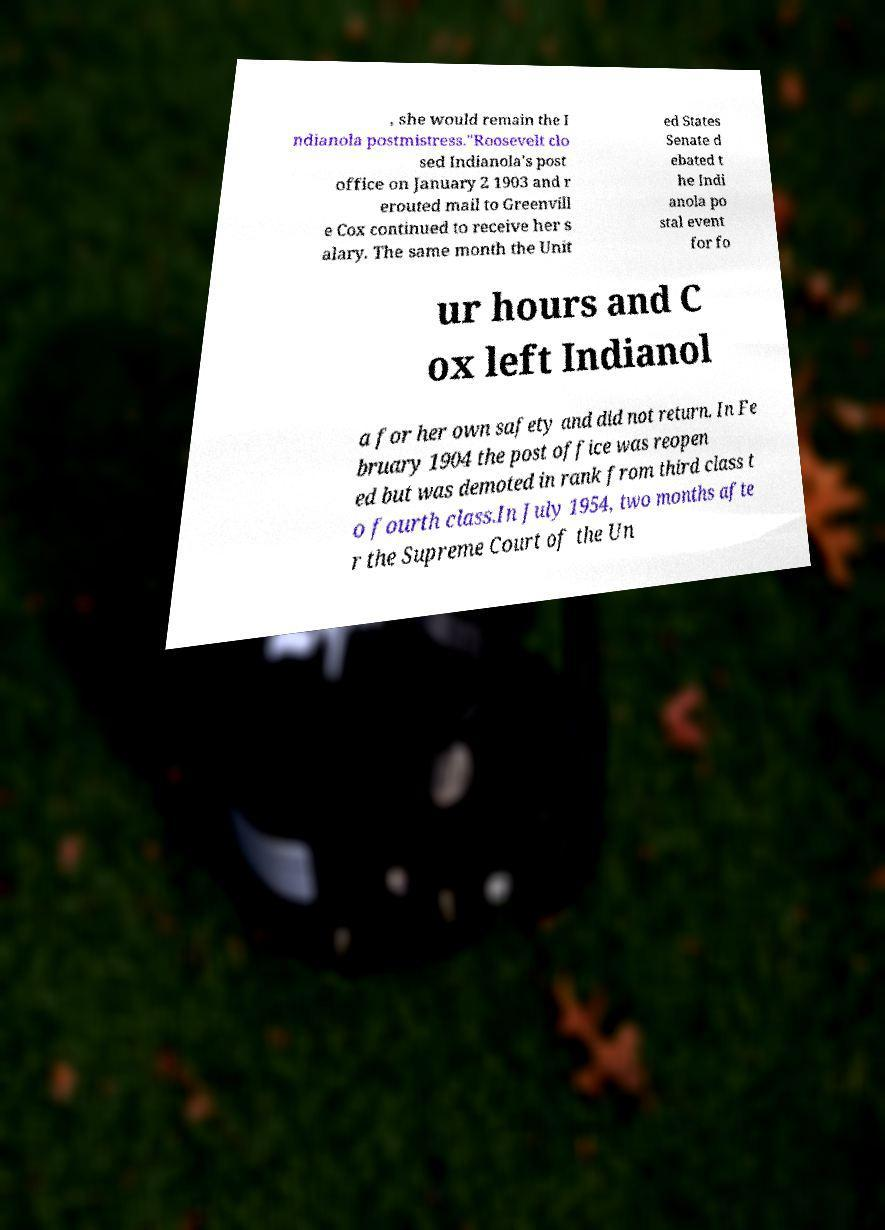Could you extract and type out the text from this image? , she would remain the I ndianola postmistress."Roosevelt clo sed Indianola's post office on January 2 1903 and r erouted mail to Greenvill e Cox continued to receive her s alary. The same month the Unit ed States Senate d ebated t he Indi anola po stal event for fo ur hours and C ox left Indianol a for her own safety and did not return. In Fe bruary 1904 the post office was reopen ed but was demoted in rank from third class t o fourth class.In July 1954, two months afte r the Supreme Court of the Un 